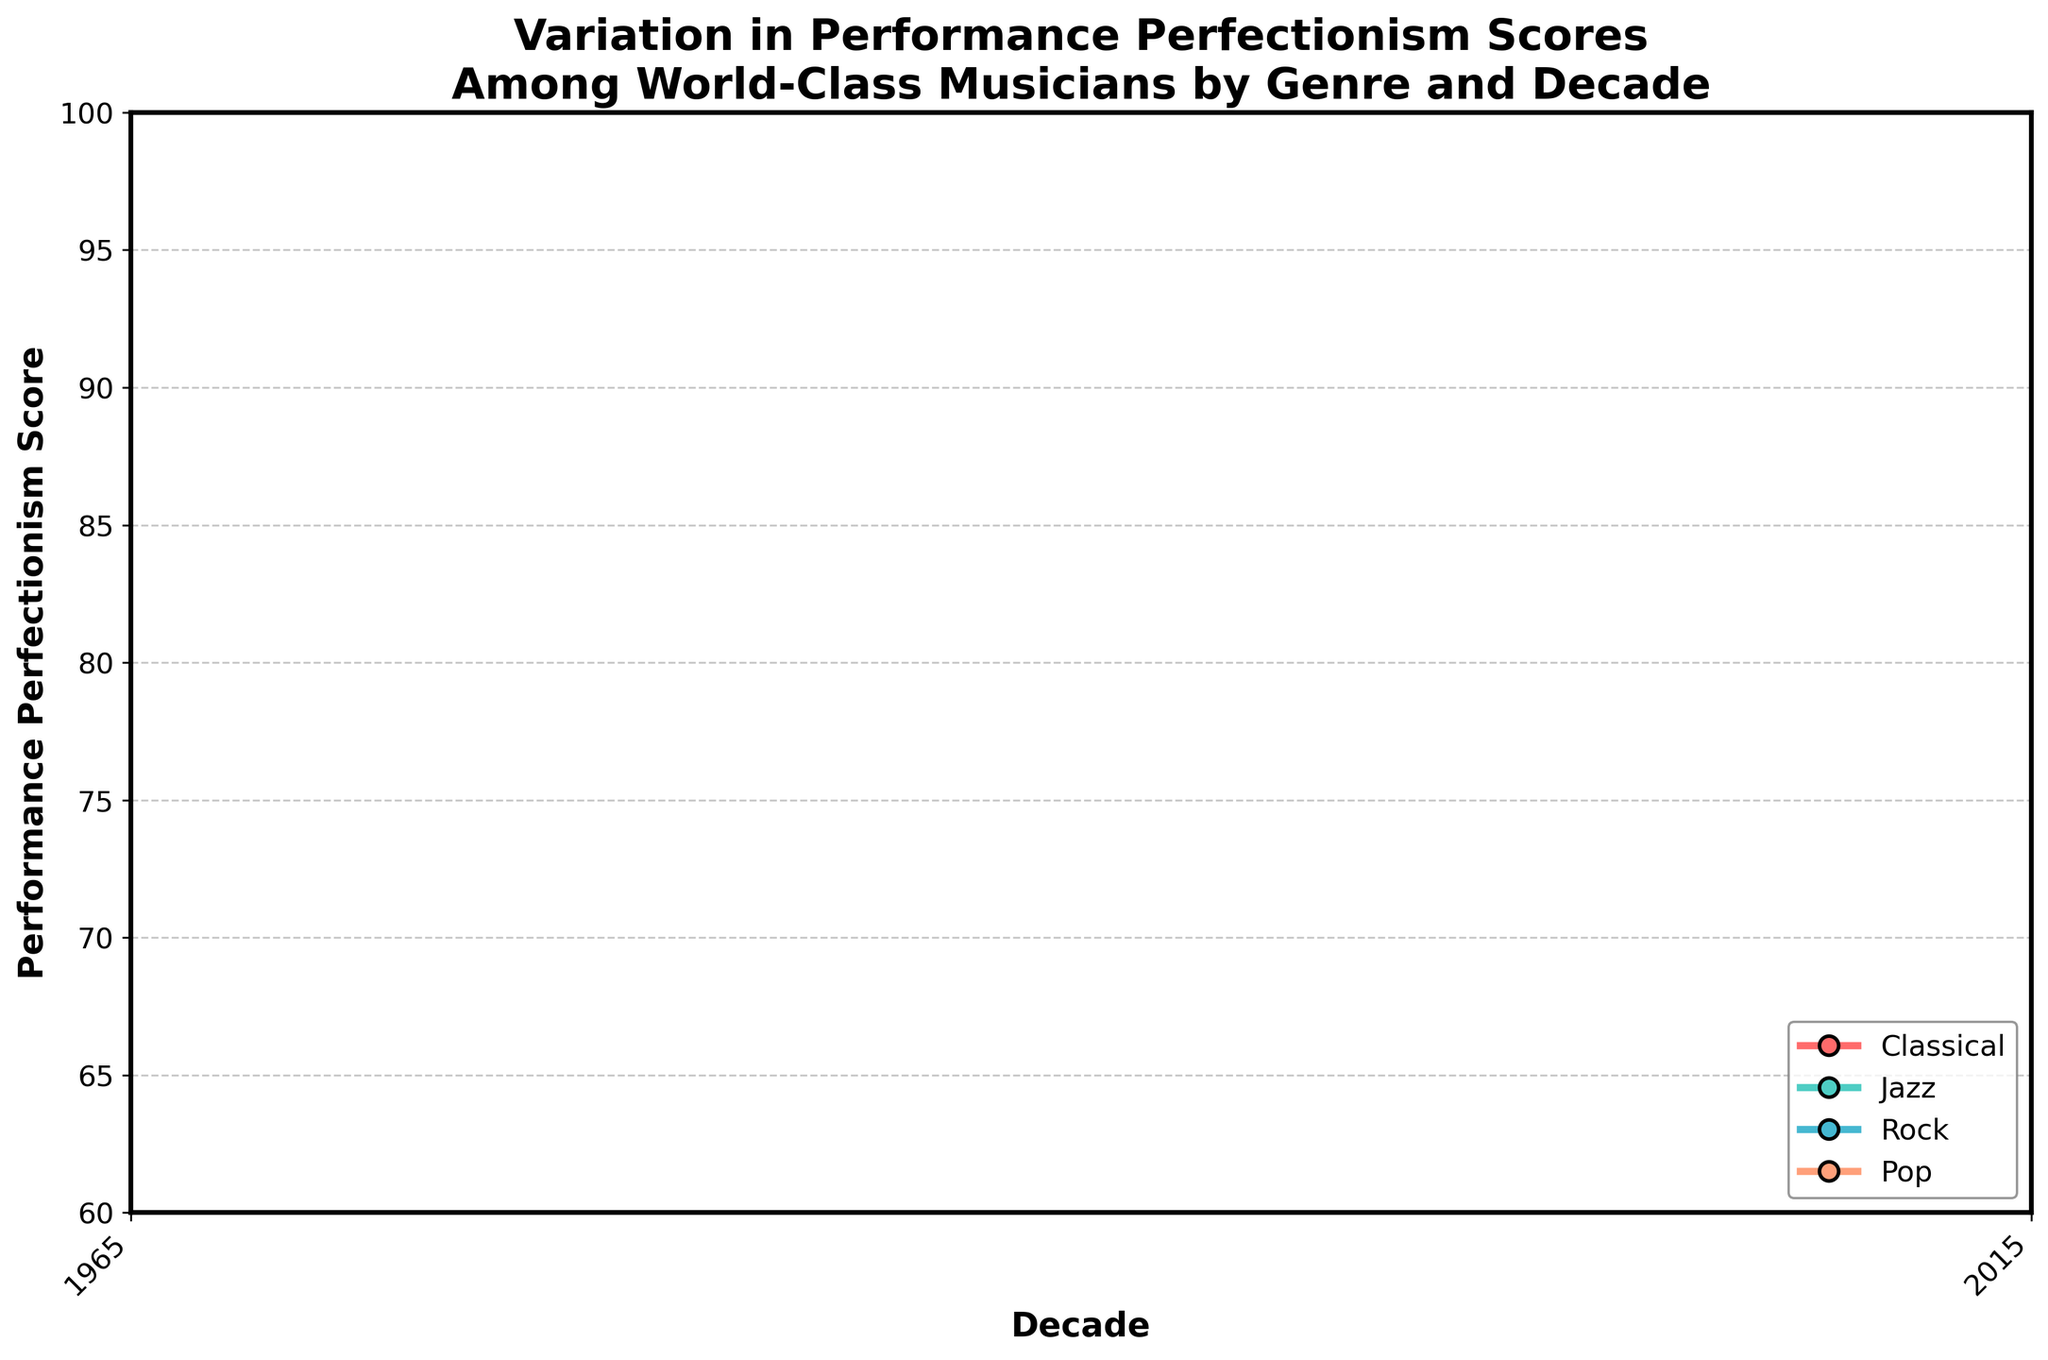What's the highest Performance Perfectionism Score recorded in the figure? The highest Performance Perfectionism Score can be determined by looking at the y-axis values and identifying the peak score across all genres and decades. The highest value is for Classical music in the 2010s at 94.
Answer: 94 Which genre shows the lowest Performance Perfectionism Score in the 1970s? To find the genre with the lowest score in the 1970s, check the y-values for all genres in that decade. Rock shows the lowest score at 65.
Answer: Rock What's the total increase in Performance Perfectionism Score for Classical music from the 1970s to the 2010s? Calculate the difference between the scores in the 2010s and the 1970s for Classical music. The increase is 94 - 87 = 7.
Answer: 7 Between Jazz and Pop, which genre had a higher Performance Perfectionism Score in the 2000s? Compare the scores for Jazz and Pop in the 2000s. Jazz is at 78, while Pop is at 77. Hence, Jazz had a higher score.
Answer: Jazz Are there any genres whose Performance Perfectionism Score increased consistently every decade from the 1970s to the 2010s? By inspecting the step plot for each genre, we can note that Classical, Jazz, Rock, and Pop all show consistent increases each decade.
Answer: Yes What's the average Performance Perfectionism Score for all genres in the 1990s? Sum the scores of all genres in the 1990s and divide by the number of genres. (91 + 76 + 70 + 75) / 4 = 78.
Answer: 78 How much did the Performance Perfectionism Score for Rock change from the 1970s to the 2000s? Subtract the 1970s score from the 2000s score for Rock. The change is 71 - 65 = 6.
Answer: 6 Which genre shows the least variation in Performance Perfectionism Scores over the decades? Evaluate the difference between the highest and lowest scores for each genre. Jazz ranges from 72 to 80 (difference of 8), which is the least compared to other genres.
Answer: Jazz What's the most significant performance perfectionism score increase in any genre within a decade interval? Examine decade-to-decade increases for all genres. Classical increases from 89 to 91 (2) from 1980s to 1990s and 91 to 92 (1) in 2000s, showing various increases. Jazz increased by 2 or 3 at maximum in intervals. Rock increased by 3 from 1970s to 1980s. Pop increased by 3 from 1970s to 1980s. The highest is Classical's increase from 2010s to 94 (2).
Answer: Classical (1980s-1990s, 2 points) 